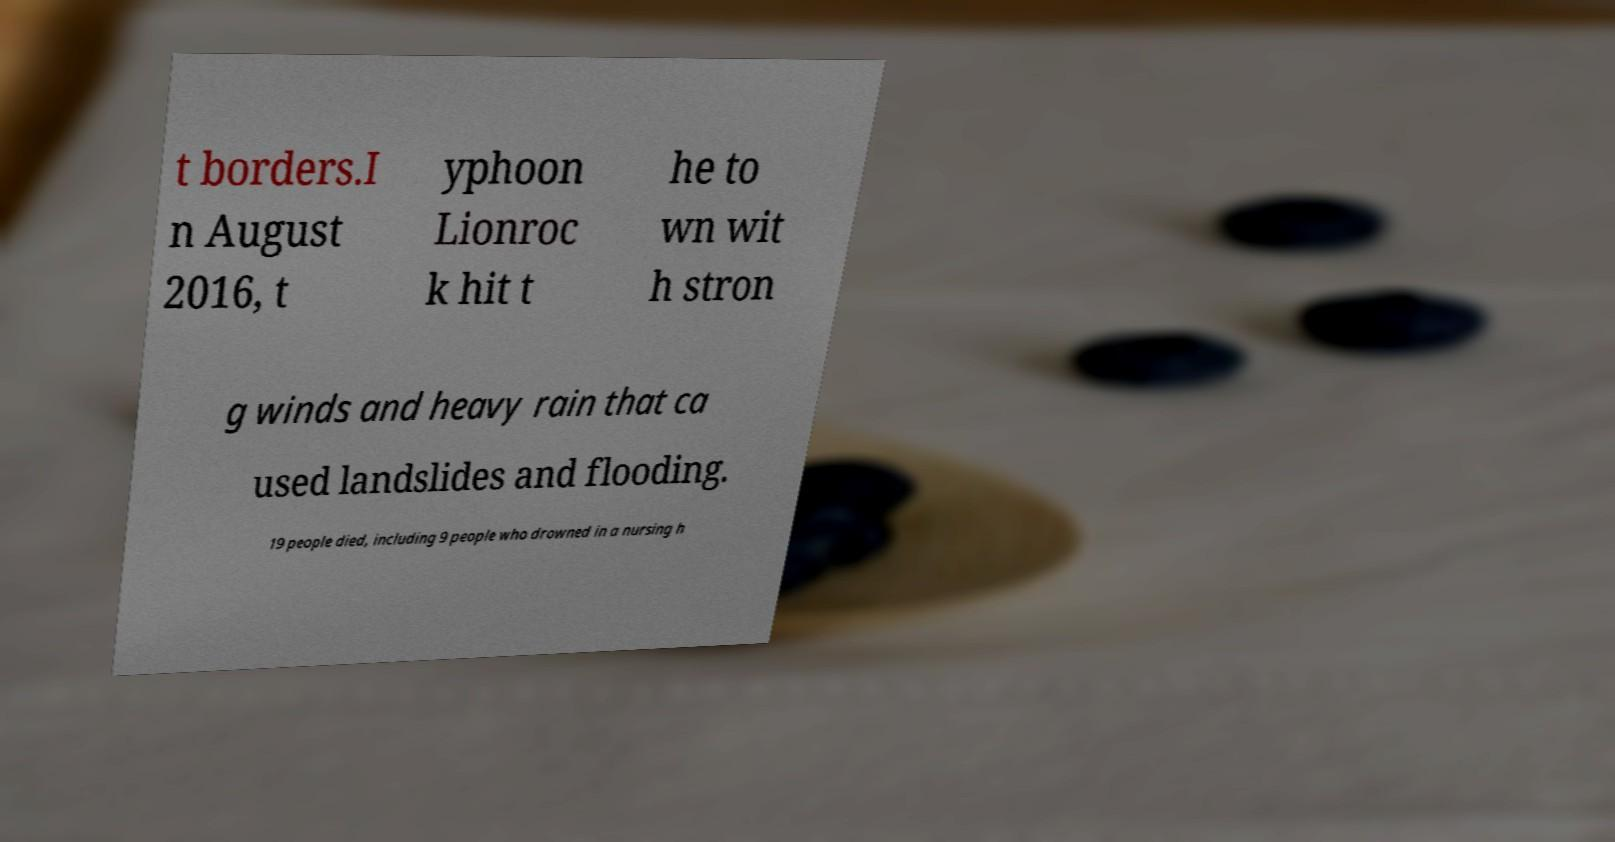Could you extract and type out the text from this image? t borders.I n August 2016, t yphoon Lionroc k hit t he to wn wit h stron g winds and heavy rain that ca used landslides and flooding. 19 people died, including 9 people who drowned in a nursing h 